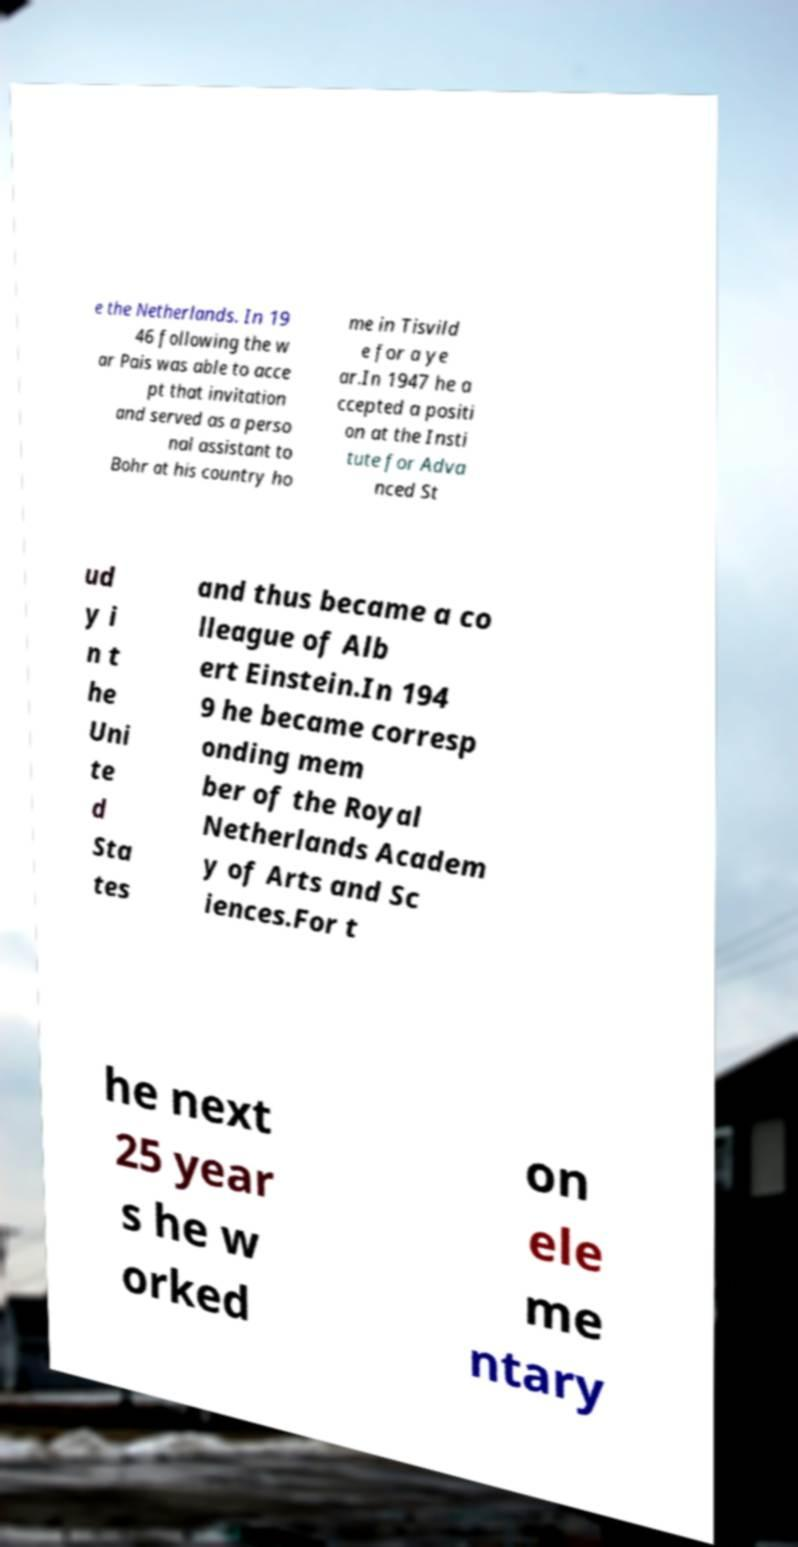Can you read and provide the text displayed in the image?This photo seems to have some interesting text. Can you extract and type it out for me? e the Netherlands. In 19 46 following the w ar Pais was able to acce pt that invitation and served as a perso nal assistant to Bohr at his country ho me in Tisvild e for a ye ar.In 1947 he a ccepted a positi on at the Insti tute for Adva nced St ud y i n t he Uni te d Sta tes and thus became a co lleague of Alb ert Einstein.In 194 9 he became corresp onding mem ber of the Royal Netherlands Academ y of Arts and Sc iences.For t he next 25 year s he w orked on ele me ntary 